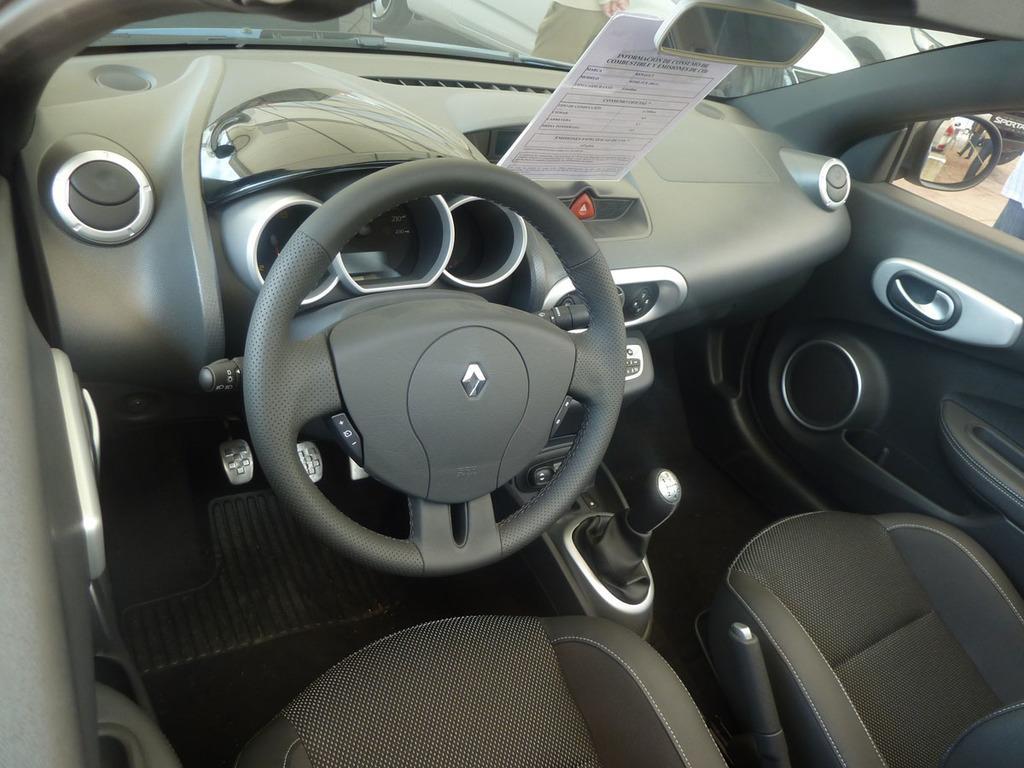Please provide a concise description of this image. This image is taken from inside the car. In this image there are seats, steering, gear, door, window, front mirror, through the mirror, we can see there are a few people and a few vehicles. 